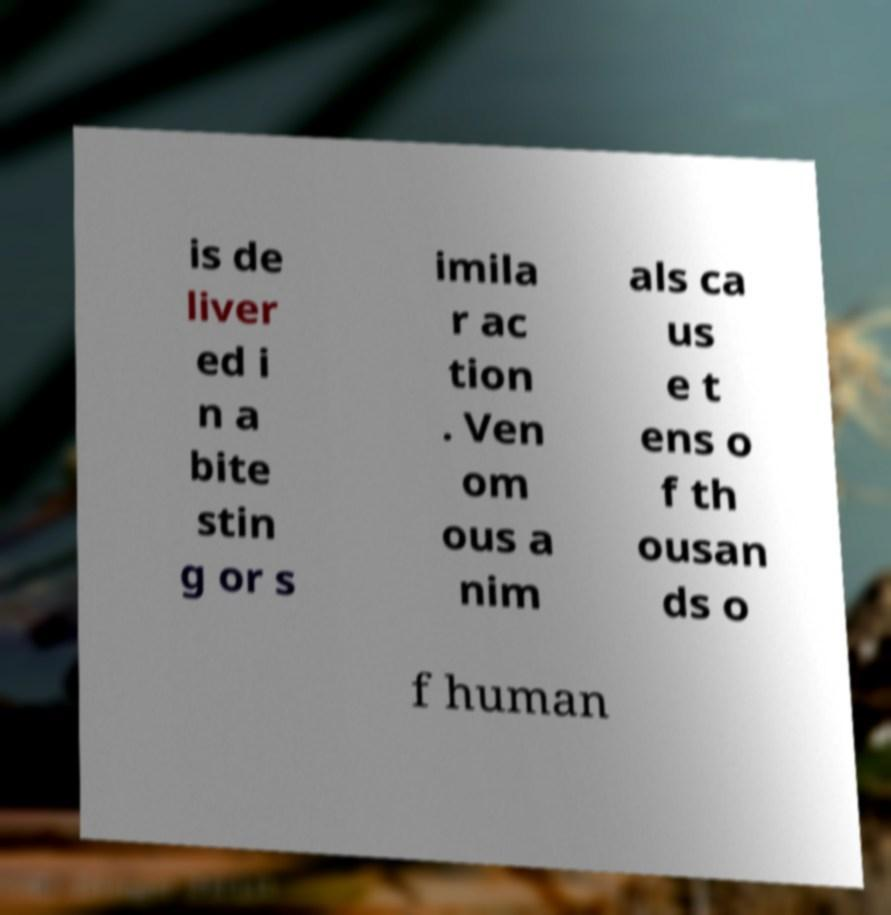Can you accurately transcribe the text from the provided image for me? is de liver ed i n a bite stin g or s imila r ac tion . Ven om ous a nim als ca us e t ens o f th ousan ds o f human 